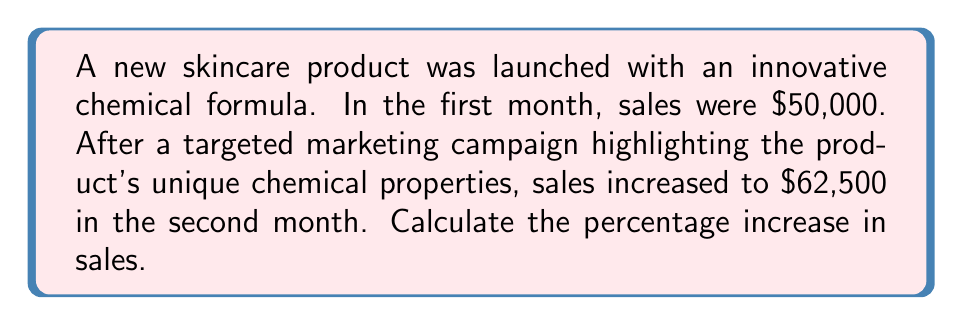What is the answer to this math problem? To calculate the percentage increase in sales, we'll follow these steps:

1. Calculate the difference in sales:
   $\text{Increase} = \text{New Sales} - \text{Original Sales}$
   $\text{Increase} = \$62,500 - \$50,000 = \$12,500$

2. Divide the increase by the original sales:
   $\frac{\text{Increase}}{\text{Original Sales}} = \frac{\$12,500}{\$50,000} = 0.25$

3. Convert the decimal to a percentage by multiplying by 100:
   $\text{Percentage Increase} = 0.25 \times 100 = 25\%$

Therefore, the percentage increase in sales after the marketing campaign is 25%.

Alternatively, we can use the percentage change formula:

$$\text{Percentage Change} = \frac{\text{New Value} - \text{Original Value}}{\text{Original Value}} \times 100\%$$

$$\text{Percentage Change} = \frac{\$62,500 - \$50,000}{\$50,000} \times 100\% = \frac{\$12,500}{\$50,000} \times 100\% = 0.25 \times 100\% = 25\%$$
Answer: 25% 